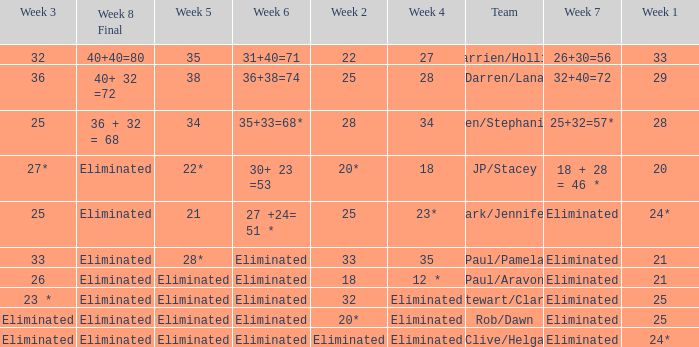Name the team for week 1 of 33 Darrien/Hollie. 